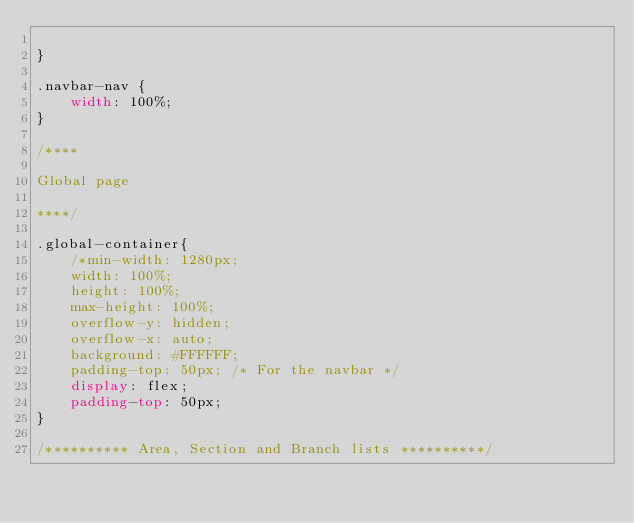<code> <loc_0><loc_0><loc_500><loc_500><_CSS_>
}

.navbar-nav {
	width: 100%;
}

/****
	
Global page

****/

.global-container{
	/*min-width: 1280px;
	width: 100%;
	height: 100%;
	max-height: 100%;
	overflow-y: hidden;
	overflow-x: auto;
	background: #FFFFFF;
	padding-top: 50px; /* For the navbar */
	display: flex;
	padding-top: 50px;
}

/********** Area, Section and Branch lists **********/
</code> 